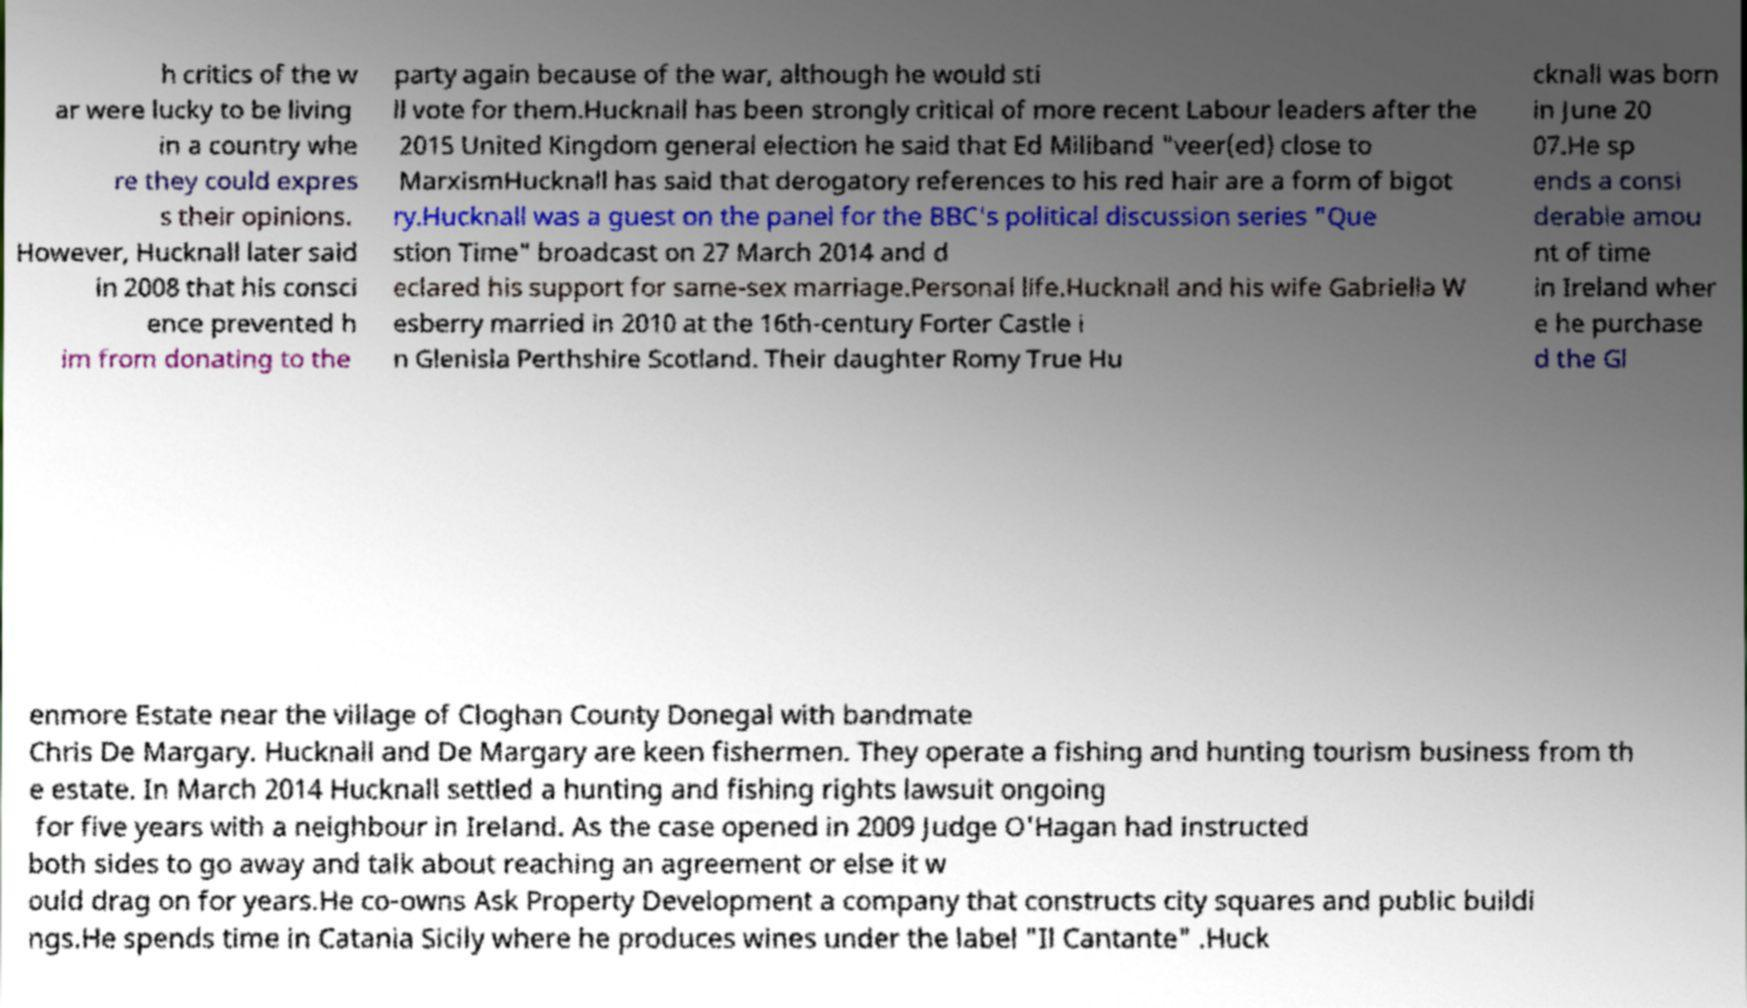Could you assist in decoding the text presented in this image and type it out clearly? h critics of the w ar were lucky to be living in a country whe re they could expres s their opinions. However, Hucknall later said in 2008 that his consci ence prevented h im from donating to the party again because of the war, although he would sti ll vote for them.Hucknall has been strongly critical of more recent Labour leaders after the 2015 United Kingdom general election he said that Ed Miliband "veer(ed) close to MarxismHucknall has said that derogatory references to his red hair are a form of bigot ry.Hucknall was a guest on the panel for the BBC's political discussion series "Que stion Time" broadcast on 27 March 2014 and d eclared his support for same-sex marriage.Personal life.Hucknall and his wife Gabriella W esberry married in 2010 at the 16th-century Forter Castle i n Glenisla Perthshire Scotland. Their daughter Romy True Hu cknall was born in June 20 07.He sp ends a consi derable amou nt of time in Ireland wher e he purchase d the Gl enmore Estate near the village of Cloghan County Donegal with bandmate Chris De Margary. Hucknall and De Margary are keen fishermen. They operate a fishing and hunting tourism business from th e estate. In March 2014 Hucknall settled a hunting and fishing rights lawsuit ongoing for five years with a neighbour in Ireland. As the case opened in 2009 Judge O'Hagan had instructed both sides to go away and talk about reaching an agreement or else it w ould drag on for years.He co-owns Ask Property Development a company that constructs city squares and public buildi ngs.He spends time in Catania Sicily where he produces wines under the label "Il Cantante" .Huck 